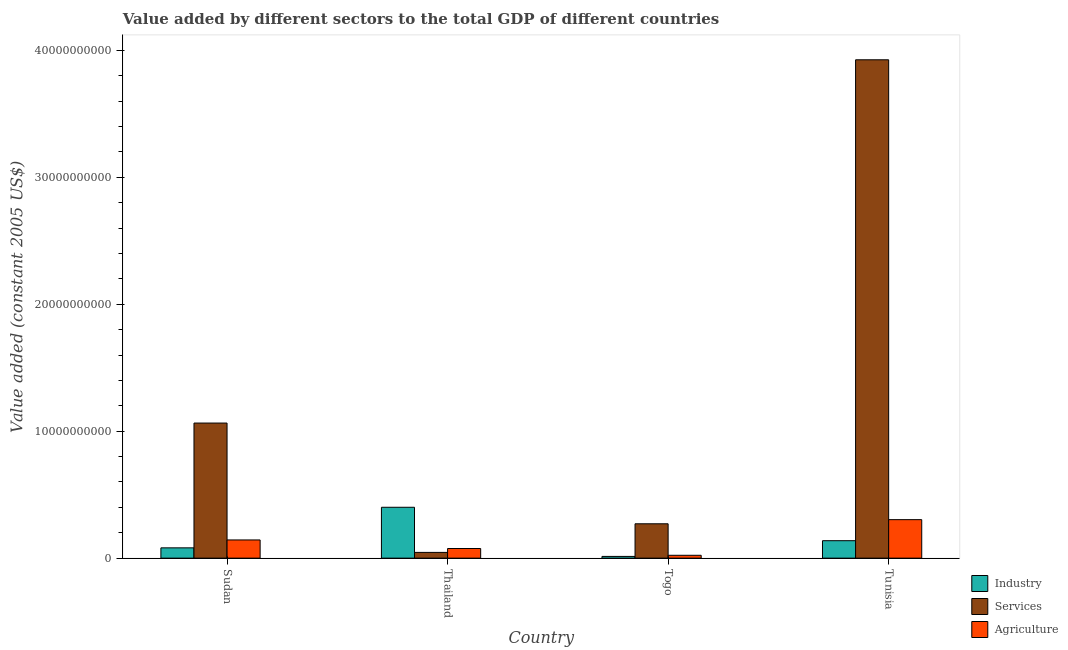How many bars are there on the 2nd tick from the left?
Offer a very short reply. 3. What is the label of the 4th group of bars from the left?
Offer a terse response. Tunisia. What is the value added by services in Togo?
Your answer should be compact. 2.71e+09. Across all countries, what is the maximum value added by services?
Ensure brevity in your answer.  3.93e+1. Across all countries, what is the minimum value added by industrial sector?
Make the answer very short. 1.37e+08. In which country was the value added by services maximum?
Your answer should be very brief. Tunisia. In which country was the value added by industrial sector minimum?
Provide a short and direct response. Togo. What is the total value added by industrial sector in the graph?
Your answer should be very brief. 6.33e+09. What is the difference between the value added by services in Thailand and that in Tunisia?
Give a very brief answer. -3.88e+1. What is the difference between the value added by agricultural sector in Sudan and the value added by services in Thailand?
Offer a very short reply. 9.81e+08. What is the average value added by services per country?
Give a very brief answer. 1.33e+1. What is the difference between the value added by industrial sector and value added by agricultural sector in Thailand?
Provide a short and direct response. 3.25e+09. In how many countries, is the value added by services greater than 30000000000 US$?
Ensure brevity in your answer.  1. What is the ratio of the value added by agricultural sector in Thailand to that in Togo?
Your answer should be compact. 3.37. Is the value added by agricultural sector in Sudan less than that in Thailand?
Your answer should be very brief. No. Is the difference between the value added by agricultural sector in Sudan and Tunisia greater than the difference between the value added by services in Sudan and Tunisia?
Provide a succinct answer. Yes. What is the difference between the highest and the second highest value added by industrial sector?
Your answer should be compact. 2.63e+09. What is the difference between the highest and the lowest value added by industrial sector?
Offer a very short reply. 3.87e+09. Is the sum of the value added by agricultural sector in Sudan and Thailand greater than the maximum value added by industrial sector across all countries?
Provide a succinct answer. No. What does the 2nd bar from the left in Tunisia represents?
Make the answer very short. Services. What does the 1st bar from the right in Sudan represents?
Your answer should be compact. Agriculture. How many bars are there?
Your response must be concise. 12. Are all the bars in the graph horizontal?
Ensure brevity in your answer.  No. What is the difference between two consecutive major ticks on the Y-axis?
Your answer should be very brief. 1.00e+1. Does the graph contain any zero values?
Provide a succinct answer. No. How many legend labels are there?
Offer a very short reply. 3. How are the legend labels stacked?
Your answer should be compact. Vertical. What is the title of the graph?
Provide a succinct answer. Value added by different sectors to the total GDP of different countries. Does "Primary education" appear as one of the legend labels in the graph?
Your answer should be compact. No. What is the label or title of the Y-axis?
Your answer should be very brief. Value added (constant 2005 US$). What is the Value added (constant 2005 US$) in Industry in Sudan?
Offer a very short reply. 8.12e+08. What is the Value added (constant 2005 US$) in Services in Sudan?
Provide a succinct answer. 1.06e+1. What is the Value added (constant 2005 US$) of Agriculture in Sudan?
Offer a very short reply. 1.43e+09. What is the Value added (constant 2005 US$) in Industry in Thailand?
Provide a short and direct response. 4.01e+09. What is the Value added (constant 2005 US$) of Services in Thailand?
Provide a succinct answer. 4.53e+08. What is the Value added (constant 2005 US$) of Agriculture in Thailand?
Provide a short and direct response. 7.59e+08. What is the Value added (constant 2005 US$) of Industry in Togo?
Provide a succinct answer. 1.37e+08. What is the Value added (constant 2005 US$) in Services in Togo?
Provide a short and direct response. 2.71e+09. What is the Value added (constant 2005 US$) in Agriculture in Togo?
Give a very brief answer. 2.25e+08. What is the Value added (constant 2005 US$) in Industry in Tunisia?
Your answer should be very brief. 1.37e+09. What is the Value added (constant 2005 US$) of Services in Tunisia?
Make the answer very short. 3.93e+1. What is the Value added (constant 2005 US$) of Agriculture in Tunisia?
Make the answer very short. 3.03e+09. Across all countries, what is the maximum Value added (constant 2005 US$) in Industry?
Provide a succinct answer. 4.01e+09. Across all countries, what is the maximum Value added (constant 2005 US$) of Services?
Offer a very short reply. 3.93e+1. Across all countries, what is the maximum Value added (constant 2005 US$) in Agriculture?
Your answer should be very brief. 3.03e+09. Across all countries, what is the minimum Value added (constant 2005 US$) in Industry?
Your response must be concise. 1.37e+08. Across all countries, what is the minimum Value added (constant 2005 US$) of Services?
Offer a very short reply. 4.53e+08. Across all countries, what is the minimum Value added (constant 2005 US$) in Agriculture?
Make the answer very short. 2.25e+08. What is the total Value added (constant 2005 US$) in Industry in the graph?
Make the answer very short. 6.33e+09. What is the total Value added (constant 2005 US$) of Services in the graph?
Make the answer very short. 5.31e+1. What is the total Value added (constant 2005 US$) of Agriculture in the graph?
Ensure brevity in your answer.  5.45e+09. What is the difference between the Value added (constant 2005 US$) in Industry in Sudan and that in Thailand?
Your answer should be compact. -3.20e+09. What is the difference between the Value added (constant 2005 US$) in Services in Sudan and that in Thailand?
Your response must be concise. 1.02e+1. What is the difference between the Value added (constant 2005 US$) of Agriculture in Sudan and that in Thailand?
Offer a very short reply. 6.75e+08. What is the difference between the Value added (constant 2005 US$) of Industry in Sudan and that in Togo?
Ensure brevity in your answer.  6.75e+08. What is the difference between the Value added (constant 2005 US$) of Services in Sudan and that in Togo?
Make the answer very short. 7.93e+09. What is the difference between the Value added (constant 2005 US$) in Agriculture in Sudan and that in Togo?
Your response must be concise. 1.21e+09. What is the difference between the Value added (constant 2005 US$) of Industry in Sudan and that in Tunisia?
Provide a short and direct response. -5.63e+08. What is the difference between the Value added (constant 2005 US$) of Services in Sudan and that in Tunisia?
Your answer should be compact. -2.86e+1. What is the difference between the Value added (constant 2005 US$) in Agriculture in Sudan and that in Tunisia?
Your answer should be compact. -1.60e+09. What is the difference between the Value added (constant 2005 US$) in Industry in Thailand and that in Togo?
Keep it short and to the point. 3.87e+09. What is the difference between the Value added (constant 2005 US$) in Services in Thailand and that in Togo?
Provide a short and direct response. -2.25e+09. What is the difference between the Value added (constant 2005 US$) of Agriculture in Thailand and that in Togo?
Keep it short and to the point. 5.34e+08. What is the difference between the Value added (constant 2005 US$) in Industry in Thailand and that in Tunisia?
Provide a succinct answer. 2.63e+09. What is the difference between the Value added (constant 2005 US$) in Services in Thailand and that in Tunisia?
Your answer should be very brief. -3.88e+1. What is the difference between the Value added (constant 2005 US$) of Agriculture in Thailand and that in Tunisia?
Keep it short and to the point. -2.27e+09. What is the difference between the Value added (constant 2005 US$) in Industry in Togo and that in Tunisia?
Ensure brevity in your answer.  -1.24e+09. What is the difference between the Value added (constant 2005 US$) of Services in Togo and that in Tunisia?
Provide a succinct answer. -3.65e+1. What is the difference between the Value added (constant 2005 US$) of Agriculture in Togo and that in Tunisia?
Your response must be concise. -2.81e+09. What is the difference between the Value added (constant 2005 US$) of Industry in Sudan and the Value added (constant 2005 US$) of Services in Thailand?
Your answer should be compact. 3.59e+08. What is the difference between the Value added (constant 2005 US$) of Industry in Sudan and the Value added (constant 2005 US$) of Agriculture in Thailand?
Make the answer very short. 5.27e+07. What is the difference between the Value added (constant 2005 US$) of Services in Sudan and the Value added (constant 2005 US$) of Agriculture in Thailand?
Your answer should be very brief. 9.88e+09. What is the difference between the Value added (constant 2005 US$) in Industry in Sudan and the Value added (constant 2005 US$) in Services in Togo?
Give a very brief answer. -1.89e+09. What is the difference between the Value added (constant 2005 US$) in Industry in Sudan and the Value added (constant 2005 US$) in Agriculture in Togo?
Your answer should be compact. 5.86e+08. What is the difference between the Value added (constant 2005 US$) in Services in Sudan and the Value added (constant 2005 US$) in Agriculture in Togo?
Offer a very short reply. 1.04e+1. What is the difference between the Value added (constant 2005 US$) in Industry in Sudan and the Value added (constant 2005 US$) in Services in Tunisia?
Your answer should be very brief. -3.84e+1. What is the difference between the Value added (constant 2005 US$) in Industry in Sudan and the Value added (constant 2005 US$) in Agriculture in Tunisia?
Your response must be concise. -2.22e+09. What is the difference between the Value added (constant 2005 US$) in Services in Sudan and the Value added (constant 2005 US$) in Agriculture in Tunisia?
Provide a short and direct response. 7.61e+09. What is the difference between the Value added (constant 2005 US$) in Industry in Thailand and the Value added (constant 2005 US$) in Services in Togo?
Your answer should be compact. 1.30e+09. What is the difference between the Value added (constant 2005 US$) of Industry in Thailand and the Value added (constant 2005 US$) of Agriculture in Togo?
Offer a very short reply. 3.78e+09. What is the difference between the Value added (constant 2005 US$) of Services in Thailand and the Value added (constant 2005 US$) of Agriculture in Togo?
Make the answer very short. 2.28e+08. What is the difference between the Value added (constant 2005 US$) in Industry in Thailand and the Value added (constant 2005 US$) in Services in Tunisia?
Your answer should be compact. -3.52e+1. What is the difference between the Value added (constant 2005 US$) in Industry in Thailand and the Value added (constant 2005 US$) in Agriculture in Tunisia?
Ensure brevity in your answer.  9.75e+08. What is the difference between the Value added (constant 2005 US$) in Services in Thailand and the Value added (constant 2005 US$) in Agriculture in Tunisia?
Provide a short and direct response. -2.58e+09. What is the difference between the Value added (constant 2005 US$) of Industry in Togo and the Value added (constant 2005 US$) of Services in Tunisia?
Make the answer very short. -3.91e+1. What is the difference between the Value added (constant 2005 US$) in Industry in Togo and the Value added (constant 2005 US$) in Agriculture in Tunisia?
Your answer should be compact. -2.90e+09. What is the difference between the Value added (constant 2005 US$) of Services in Togo and the Value added (constant 2005 US$) of Agriculture in Tunisia?
Provide a short and direct response. -3.26e+08. What is the average Value added (constant 2005 US$) of Industry per country?
Your answer should be compact. 1.58e+09. What is the average Value added (constant 2005 US$) of Services per country?
Make the answer very short. 1.33e+1. What is the average Value added (constant 2005 US$) in Agriculture per country?
Offer a terse response. 1.36e+09. What is the difference between the Value added (constant 2005 US$) of Industry and Value added (constant 2005 US$) of Services in Sudan?
Make the answer very short. -9.83e+09. What is the difference between the Value added (constant 2005 US$) of Industry and Value added (constant 2005 US$) of Agriculture in Sudan?
Make the answer very short. -6.22e+08. What is the difference between the Value added (constant 2005 US$) in Services and Value added (constant 2005 US$) in Agriculture in Sudan?
Your answer should be very brief. 9.21e+09. What is the difference between the Value added (constant 2005 US$) of Industry and Value added (constant 2005 US$) of Services in Thailand?
Your response must be concise. 3.55e+09. What is the difference between the Value added (constant 2005 US$) in Industry and Value added (constant 2005 US$) in Agriculture in Thailand?
Provide a short and direct response. 3.25e+09. What is the difference between the Value added (constant 2005 US$) in Services and Value added (constant 2005 US$) in Agriculture in Thailand?
Give a very brief answer. -3.06e+08. What is the difference between the Value added (constant 2005 US$) in Industry and Value added (constant 2005 US$) in Services in Togo?
Provide a short and direct response. -2.57e+09. What is the difference between the Value added (constant 2005 US$) in Industry and Value added (constant 2005 US$) in Agriculture in Togo?
Keep it short and to the point. -8.85e+07. What is the difference between the Value added (constant 2005 US$) of Services and Value added (constant 2005 US$) of Agriculture in Togo?
Provide a succinct answer. 2.48e+09. What is the difference between the Value added (constant 2005 US$) in Industry and Value added (constant 2005 US$) in Services in Tunisia?
Offer a very short reply. -3.79e+1. What is the difference between the Value added (constant 2005 US$) in Industry and Value added (constant 2005 US$) in Agriculture in Tunisia?
Give a very brief answer. -1.66e+09. What is the difference between the Value added (constant 2005 US$) of Services and Value added (constant 2005 US$) of Agriculture in Tunisia?
Offer a very short reply. 3.62e+1. What is the ratio of the Value added (constant 2005 US$) in Industry in Sudan to that in Thailand?
Your answer should be very brief. 0.2. What is the ratio of the Value added (constant 2005 US$) in Services in Sudan to that in Thailand?
Offer a very short reply. 23.51. What is the ratio of the Value added (constant 2005 US$) of Agriculture in Sudan to that in Thailand?
Make the answer very short. 1.89. What is the ratio of the Value added (constant 2005 US$) of Industry in Sudan to that in Togo?
Keep it short and to the point. 5.94. What is the ratio of the Value added (constant 2005 US$) of Services in Sudan to that in Togo?
Make the answer very short. 3.93. What is the ratio of the Value added (constant 2005 US$) of Agriculture in Sudan to that in Togo?
Your answer should be very brief. 6.37. What is the ratio of the Value added (constant 2005 US$) in Industry in Sudan to that in Tunisia?
Ensure brevity in your answer.  0.59. What is the ratio of the Value added (constant 2005 US$) of Services in Sudan to that in Tunisia?
Ensure brevity in your answer.  0.27. What is the ratio of the Value added (constant 2005 US$) in Agriculture in Sudan to that in Tunisia?
Provide a short and direct response. 0.47. What is the ratio of the Value added (constant 2005 US$) of Industry in Thailand to that in Togo?
Ensure brevity in your answer.  29.3. What is the ratio of the Value added (constant 2005 US$) in Services in Thailand to that in Togo?
Your answer should be compact. 0.17. What is the ratio of the Value added (constant 2005 US$) of Agriculture in Thailand to that in Togo?
Offer a terse response. 3.37. What is the ratio of the Value added (constant 2005 US$) of Industry in Thailand to that in Tunisia?
Give a very brief answer. 2.92. What is the ratio of the Value added (constant 2005 US$) in Services in Thailand to that in Tunisia?
Your response must be concise. 0.01. What is the ratio of the Value added (constant 2005 US$) of Agriculture in Thailand to that in Tunisia?
Give a very brief answer. 0.25. What is the ratio of the Value added (constant 2005 US$) in Industry in Togo to that in Tunisia?
Offer a very short reply. 0.1. What is the ratio of the Value added (constant 2005 US$) of Services in Togo to that in Tunisia?
Make the answer very short. 0.07. What is the ratio of the Value added (constant 2005 US$) of Agriculture in Togo to that in Tunisia?
Provide a short and direct response. 0.07. What is the difference between the highest and the second highest Value added (constant 2005 US$) in Industry?
Make the answer very short. 2.63e+09. What is the difference between the highest and the second highest Value added (constant 2005 US$) in Services?
Offer a very short reply. 2.86e+1. What is the difference between the highest and the second highest Value added (constant 2005 US$) of Agriculture?
Provide a short and direct response. 1.60e+09. What is the difference between the highest and the lowest Value added (constant 2005 US$) of Industry?
Your response must be concise. 3.87e+09. What is the difference between the highest and the lowest Value added (constant 2005 US$) of Services?
Provide a succinct answer. 3.88e+1. What is the difference between the highest and the lowest Value added (constant 2005 US$) of Agriculture?
Provide a succinct answer. 2.81e+09. 